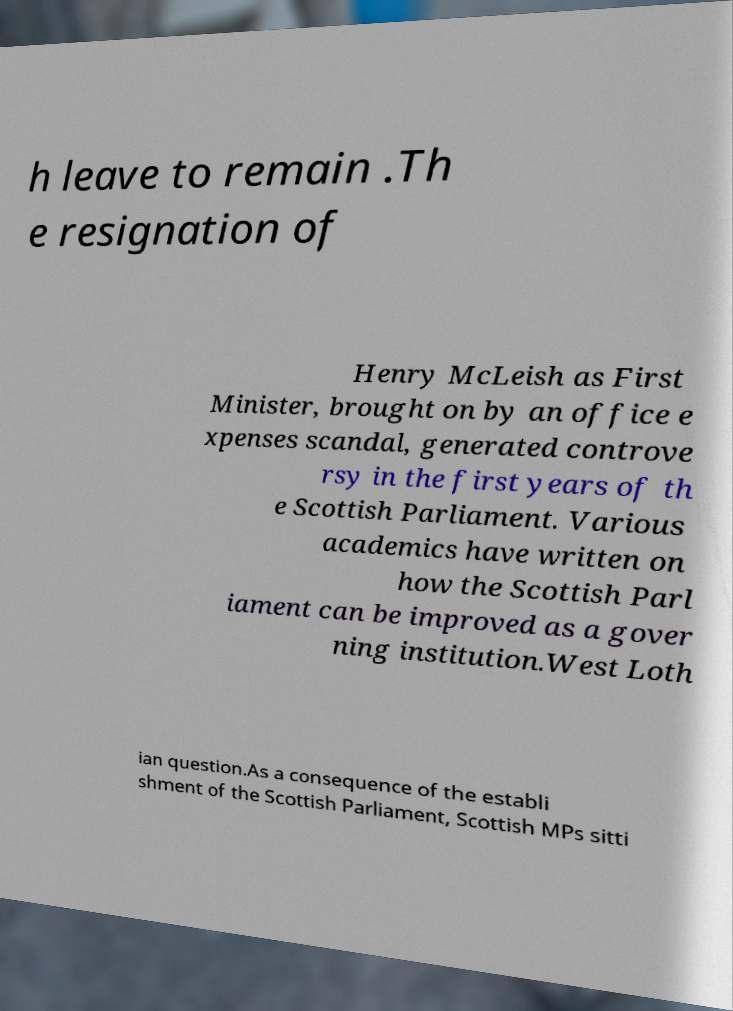There's text embedded in this image that I need extracted. Can you transcribe it verbatim? h leave to remain .Th e resignation of Henry McLeish as First Minister, brought on by an office e xpenses scandal, generated controve rsy in the first years of th e Scottish Parliament. Various academics have written on how the Scottish Parl iament can be improved as a gover ning institution.West Loth ian question.As a consequence of the establi shment of the Scottish Parliament, Scottish MPs sitti 